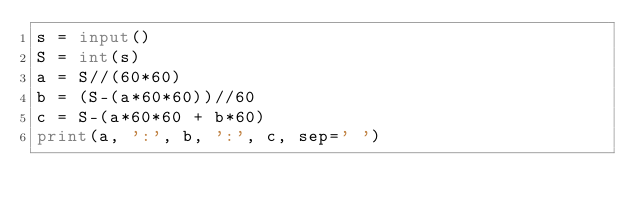Convert code to text. <code><loc_0><loc_0><loc_500><loc_500><_Python_>s = input()
S = int(s)
a = S//(60*60)
b = (S-(a*60*60))//60
c = S-(a*60*60 + b*60)
print(a, ':', b, ':', c, sep=' ')
</code> 